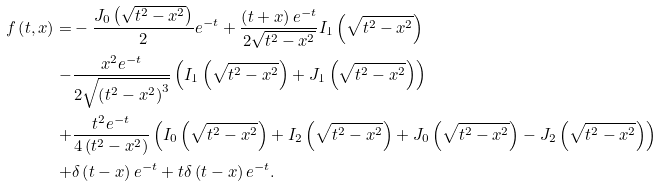Convert formula to latex. <formula><loc_0><loc_0><loc_500><loc_500>f \left ( t , x \right ) = & - \frac { J _ { 0 } \left ( \sqrt { t ^ { 2 } - x ^ { 2 } } \right ) } { 2 } e ^ { - t } + \frac { \left ( t + x \right ) e ^ { - t } } { 2 \sqrt { t ^ { 2 } - x ^ { 2 } } } I _ { 1 } \left ( \sqrt { t ^ { 2 } - x ^ { 2 } } \right ) \\ - & \frac { x ^ { 2 } e ^ { - t } } { 2 \sqrt { { \left ( t ^ { 2 } - x ^ { 2 } \right ) } ^ { 3 } } } \left ( I _ { 1 } \left ( \sqrt { t ^ { 2 } - x ^ { 2 } } \right ) + J _ { 1 } \left ( \sqrt { t ^ { 2 } - x ^ { 2 } } \right ) \right ) \\ + & \frac { t ^ { 2 } e ^ { - t } } { 4 \left ( t ^ { 2 } - x ^ { 2 } \right ) } \left ( I _ { 0 } \left ( \sqrt { t ^ { 2 } - x ^ { 2 } } \right ) + I _ { 2 } \left ( \sqrt { t ^ { 2 } - x ^ { 2 } } \right ) + J _ { 0 } \left ( \sqrt { t ^ { 2 } - x ^ { 2 } } \right ) - J _ { 2 } \left ( \sqrt { t ^ { 2 } - x ^ { 2 } } \right ) \right ) \\ + & \delta \left ( t - x \right ) e ^ { - t } + t \delta \left ( t - x \right ) e ^ { - t } .</formula> 